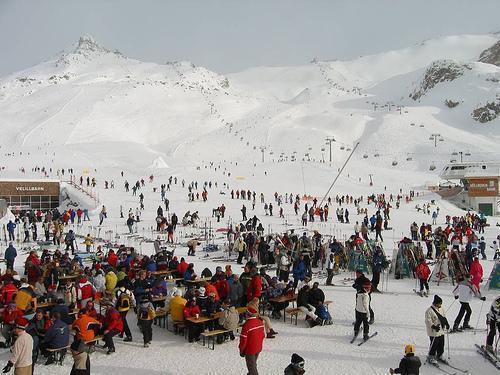What is on the floor?
Choose the right answer from the provided options to respond to the question.
Options: Milk, bananas, sand, crumbs. Sand. 